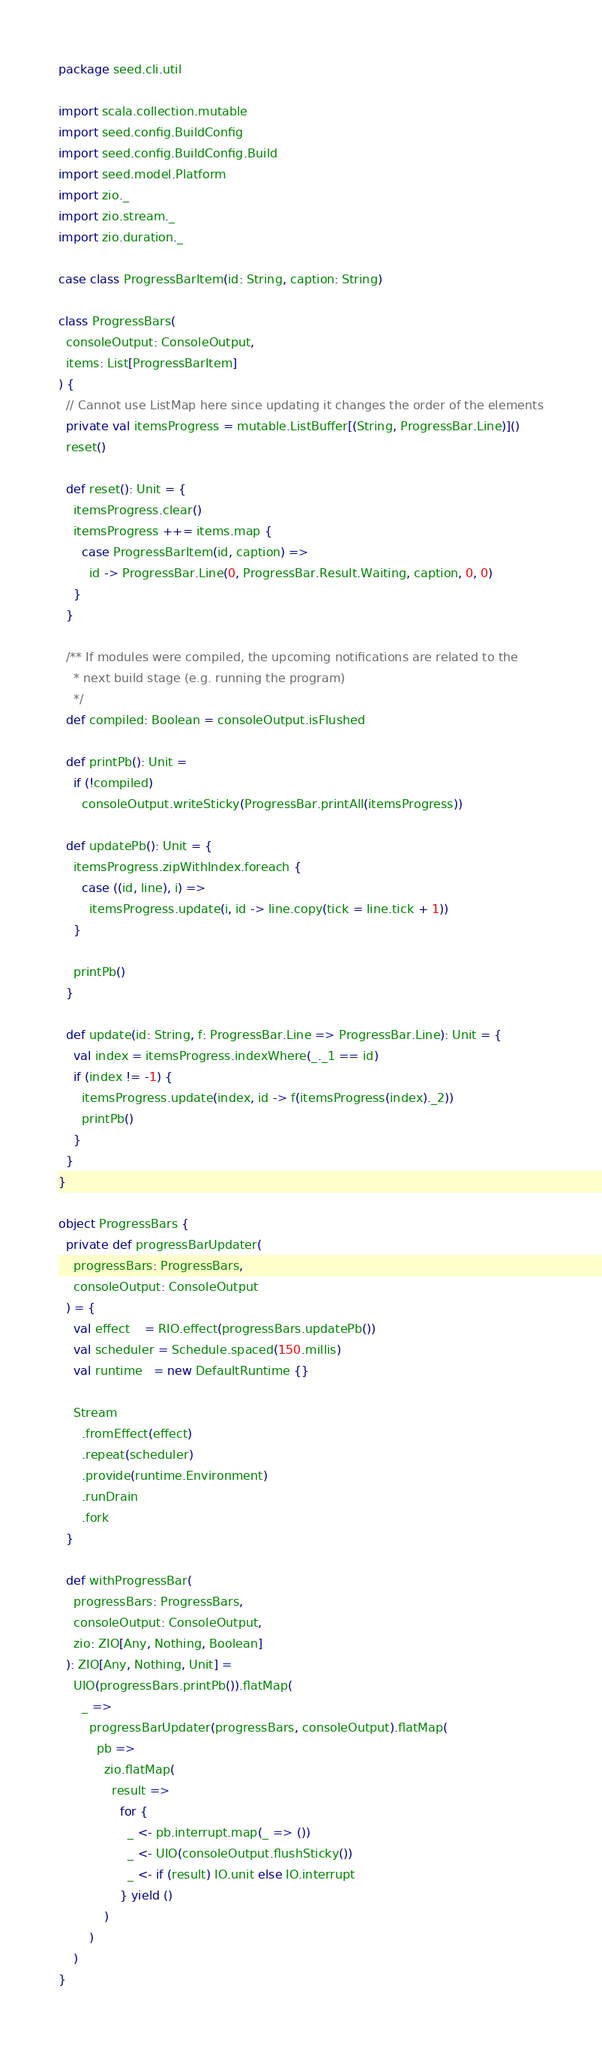Convert code to text. <code><loc_0><loc_0><loc_500><loc_500><_Scala_>package seed.cli.util

import scala.collection.mutable
import seed.config.BuildConfig
import seed.config.BuildConfig.Build
import seed.model.Platform
import zio._
import zio.stream._
import zio.duration._

case class ProgressBarItem(id: String, caption: String)

class ProgressBars(
  consoleOutput: ConsoleOutput,
  items: List[ProgressBarItem]
) {
  // Cannot use ListMap here since updating it changes the order of the elements
  private val itemsProgress = mutable.ListBuffer[(String, ProgressBar.Line)]()
  reset()

  def reset(): Unit = {
    itemsProgress.clear()
    itemsProgress ++= items.map {
      case ProgressBarItem(id, caption) =>
        id -> ProgressBar.Line(0, ProgressBar.Result.Waiting, caption, 0, 0)
    }
  }

  /** If modules were compiled, the upcoming notifications are related to the
    * next build stage (e.g. running the program)
    */
  def compiled: Boolean = consoleOutput.isFlushed

  def printPb(): Unit =
    if (!compiled)
      consoleOutput.writeSticky(ProgressBar.printAll(itemsProgress))

  def updatePb(): Unit = {
    itemsProgress.zipWithIndex.foreach {
      case ((id, line), i) =>
        itemsProgress.update(i, id -> line.copy(tick = line.tick + 1))
    }

    printPb()
  }

  def update(id: String, f: ProgressBar.Line => ProgressBar.Line): Unit = {
    val index = itemsProgress.indexWhere(_._1 == id)
    if (index != -1) {
      itemsProgress.update(index, id -> f(itemsProgress(index)._2))
      printPb()
    }
  }
}

object ProgressBars {
  private def progressBarUpdater(
    progressBars: ProgressBars,
    consoleOutput: ConsoleOutput
  ) = {
    val effect    = RIO.effect(progressBars.updatePb())
    val scheduler = Schedule.spaced(150.millis)
    val runtime   = new DefaultRuntime {}

    Stream
      .fromEffect(effect)
      .repeat(scheduler)
      .provide(runtime.Environment)
      .runDrain
      .fork
  }

  def withProgressBar(
    progressBars: ProgressBars,
    consoleOutput: ConsoleOutput,
    zio: ZIO[Any, Nothing, Boolean]
  ): ZIO[Any, Nothing, Unit] =
    UIO(progressBars.printPb()).flatMap(
      _ =>
        progressBarUpdater(progressBars, consoleOutput).flatMap(
          pb =>
            zio.flatMap(
              result =>
                for {
                  _ <- pb.interrupt.map(_ => ())
                  _ <- UIO(consoleOutput.flushSticky())
                  _ <- if (result) IO.unit else IO.interrupt
                } yield ()
            )
        )
    )
}
</code> 